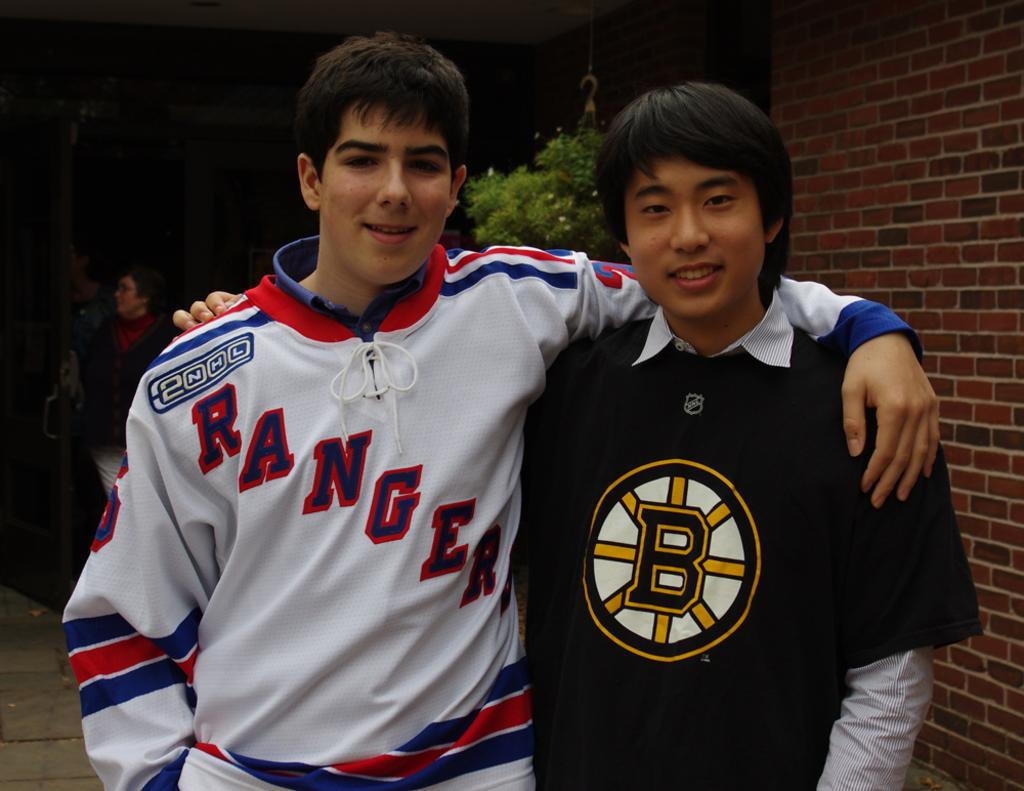Provide a one-sentence caption for the provided image. A young man in a Rangers jersey has his arm around someone with a B on his shirt. 